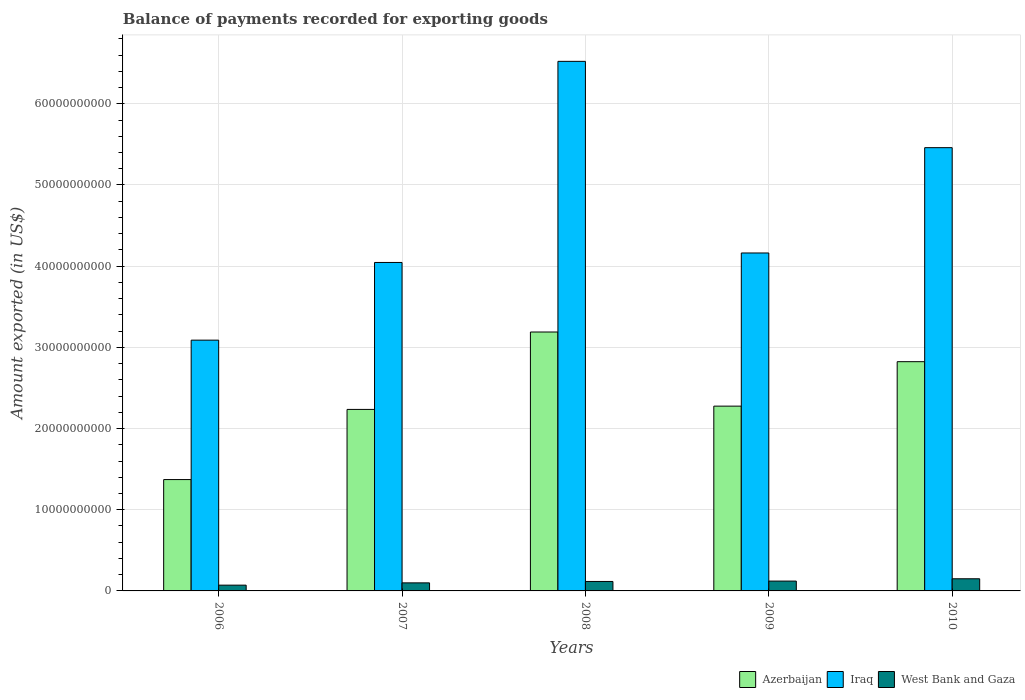Are the number of bars per tick equal to the number of legend labels?
Provide a succinct answer. Yes. Are the number of bars on each tick of the X-axis equal?
Make the answer very short. Yes. In how many cases, is the number of bars for a given year not equal to the number of legend labels?
Provide a succinct answer. 0. What is the amount exported in Iraq in 2009?
Give a very brief answer. 4.16e+1. Across all years, what is the maximum amount exported in Iraq?
Give a very brief answer. 6.52e+1. Across all years, what is the minimum amount exported in Azerbaijan?
Keep it short and to the point. 1.37e+1. In which year was the amount exported in West Bank and Gaza maximum?
Offer a terse response. 2010. In which year was the amount exported in West Bank and Gaza minimum?
Offer a terse response. 2006. What is the total amount exported in Iraq in the graph?
Your answer should be very brief. 2.33e+11. What is the difference between the amount exported in West Bank and Gaza in 2006 and that in 2009?
Provide a short and direct response. -5.00e+08. What is the difference between the amount exported in West Bank and Gaza in 2007 and the amount exported in Iraq in 2006?
Provide a short and direct response. -2.99e+1. What is the average amount exported in Iraq per year?
Give a very brief answer. 4.66e+1. In the year 2006, what is the difference between the amount exported in West Bank and Gaza and amount exported in Iraq?
Make the answer very short. -3.02e+1. What is the ratio of the amount exported in Iraq in 2006 to that in 2007?
Give a very brief answer. 0.76. Is the amount exported in Azerbaijan in 2006 less than that in 2009?
Make the answer very short. Yes. Is the difference between the amount exported in West Bank and Gaza in 2008 and 2009 greater than the difference between the amount exported in Iraq in 2008 and 2009?
Your answer should be compact. No. What is the difference between the highest and the second highest amount exported in Iraq?
Offer a terse response. 1.06e+1. What is the difference between the highest and the lowest amount exported in Iraq?
Provide a short and direct response. 3.43e+1. In how many years, is the amount exported in Azerbaijan greater than the average amount exported in Azerbaijan taken over all years?
Offer a very short reply. 2. What does the 3rd bar from the left in 2009 represents?
Provide a short and direct response. West Bank and Gaza. What does the 1st bar from the right in 2010 represents?
Your answer should be very brief. West Bank and Gaza. Is it the case that in every year, the sum of the amount exported in Azerbaijan and amount exported in Iraq is greater than the amount exported in West Bank and Gaza?
Make the answer very short. Yes. How many bars are there?
Ensure brevity in your answer.  15. What is the difference between two consecutive major ticks on the Y-axis?
Offer a terse response. 1.00e+1. Are the values on the major ticks of Y-axis written in scientific E-notation?
Your answer should be compact. No. Where does the legend appear in the graph?
Provide a succinct answer. Bottom right. How many legend labels are there?
Your answer should be compact. 3. What is the title of the graph?
Offer a very short reply. Balance of payments recorded for exporting goods. Does "Slovenia" appear as one of the legend labels in the graph?
Keep it short and to the point. No. What is the label or title of the Y-axis?
Your response must be concise. Amount exported (in US$). What is the Amount exported (in US$) of Azerbaijan in 2006?
Your answer should be very brief. 1.37e+1. What is the Amount exported (in US$) in Iraq in 2006?
Offer a very short reply. 3.09e+1. What is the Amount exported (in US$) of West Bank and Gaza in 2006?
Give a very brief answer. 7.10e+08. What is the Amount exported (in US$) of Azerbaijan in 2007?
Ensure brevity in your answer.  2.24e+1. What is the Amount exported (in US$) in Iraq in 2007?
Ensure brevity in your answer.  4.05e+1. What is the Amount exported (in US$) of West Bank and Gaza in 2007?
Ensure brevity in your answer.  9.93e+08. What is the Amount exported (in US$) in Azerbaijan in 2008?
Your response must be concise. 3.19e+1. What is the Amount exported (in US$) in Iraq in 2008?
Keep it short and to the point. 6.52e+1. What is the Amount exported (in US$) in West Bank and Gaza in 2008?
Offer a terse response. 1.16e+09. What is the Amount exported (in US$) in Azerbaijan in 2009?
Provide a succinct answer. 2.28e+1. What is the Amount exported (in US$) in Iraq in 2009?
Keep it short and to the point. 4.16e+1. What is the Amount exported (in US$) of West Bank and Gaza in 2009?
Offer a terse response. 1.21e+09. What is the Amount exported (in US$) of Azerbaijan in 2010?
Your response must be concise. 2.82e+1. What is the Amount exported (in US$) of Iraq in 2010?
Provide a short and direct response. 5.46e+1. What is the Amount exported (in US$) of West Bank and Gaza in 2010?
Offer a terse response. 1.50e+09. Across all years, what is the maximum Amount exported (in US$) of Azerbaijan?
Give a very brief answer. 3.19e+1. Across all years, what is the maximum Amount exported (in US$) in Iraq?
Provide a short and direct response. 6.52e+1. Across all years, what is the maximum Amount exported (in US$) in West Bank and Gaza?
Give a very brief answer. 1.50e+09. Across all years, what is the minimum Amount exported (in US$) of Azerbaijan?
Provide a short and direct response. 1.37e+1. Across all years, what is the minimum Amount exported (in US$) of Iraq?
Your response must be concise. 3.09e+1. Across all years, what is the minimum Amount exported (in US$) in West Bank and Gaza?
Offer a very short reply. 7.10e+08. What is the total Amount exported (in US$) of Azerbaijan in the graph?
Your answer should be compact. 1.19e+11. What is the total Amount exported (in US$) in Iraq in the graph?
Your response must be concise. 2.33e+11. What is the total Amount exported (in US$) in West Bank and Gaza in the graph?
Give a very brief answer. 5.57e+09. What is the difference between the Amount exported (in US$) of Azerbaijan in 2006 and that in 2007?
Your answer should be compact. -8.64e+09. What is the difference between the Amount exported (in US$) in Iraq in 2006 and that in 2007?
Keep it short and to the point. -9.57e+09. What is the difference between the Amount exported (in US$) in West Bank and Gaza in 2006 and that in 2007?
Provide a succinct answer. -2.82e+08. What is the difference between the Amount exported (in US$) in Azerbaijan in 2006 and that in 2008?
Offer a very short reply. -1.82e+1. What is the difference between the Amount exported (in US$) of Iraq in 2006 and that in 2008?
Give a very brief answer. -3.43e+1. What is the difference between the Amount exported (in US$) of West Bank and Gaza in 2006 and that in 2008?
Provide a short and direct response. -4.54e+08. What is the difference between the Amount exported (in US$) of Azerbaijan in 2006 and that in 2009?
Your answer should be very brief. -9.04e+09. What is the difference between the Amount exported (in US$) in Iraq in 2006 and that in 2009?
Your response must be concise. -1.07e+1. What is the difference between the Amount exported (in US$) in West Bank and Gaza in 2006 and that in 2009?
Make the answer very short. -5.00e+08. What is the difference between the Amount exported (in US$) in Azerbaijan in 2006 and that in 2010?
Provide a succinct answer. -1.45e+1. What is the difference between the Amount exported (in US$) in Iraq in 2006 and that in 2010?
Make the answer very short. -2.37e+1. What is the difference between the Amount exported (in US$) of West Bank and Gaza in 2006 and that in 2010?
Your response must be concise. -7.87e+08. What is the difference between the Amount exported (in US$) in Azerbaijan in 2007 and that in 2008?
Offer a terse response. -9.53e+09. What is the difference between the Amount exported (in US$) in Iraq in 2007 and that in 2008?
Offer a terse response. -2.48e+1. What is the difference between the Amount exported (in US$) in West Bank and Gaza in 2007 and that in 2008?
Offer a very short reply. -1.72e+08. What is the difference between the Amount exported (in US$) of Azerbaijan in 2007 and that in 2009?
Your answer should be very brief. -4.04e+08. What is the difference between the Amount exported (in US$) of Iraq in 2007 and that in 2009?
Your answer should be very brief. -1.17e+09. What is the difference between the Amount exported (in US$) in West Bank and Gaza in 2007 and that in 2009?
Offer a very short reply. -2.18e+08. What is the difference between the Amount exported (in US$) of Azerbaijan in 2007 and that in 2010?
Offer a terse response. -5.88e+09. What is the difference between the Amount exported (in US$) in Iraq in 2007 and that in 2010?
Your answer should be compact. -1.41e+1. What is the difference between the Amount exported (in US$) in West Bank and Gaza in 2007 and that in 2010?
Give a very brief answer. -5.04e+08. What is the difference between the Amount exported (in US$) of Azerbaijan in 2008 and that in 2009?
Provide a succinct answer. 9.13e+09. What is the difference between the Amount exported (in US$) of Iraq in 2008 and that in 2009?
Keep it short and to the point. 2.36e+1. What is the difference between the Amount exported (in US$) of West Bank and Gaza in 2008 and that in 2009?
Your answer should be compact. -4.61e+07. What is the difference between the Amount exported (in US$) of Azerbaijan in 2008 and that in 2010?
Provide a succinct answer. 3.65e+09. What is the difference between the Amount exported (in US$) of Iraq in 2008 and that in 2010?
Make the answer very short. 1.06e+1. What is the difference between the Amount exported (in US$) in West Bank and Gaza in 2008 and that in 2010?
Keep it short and to the point. -3.32e+08. What is the difference between the Amount exported (in US$) in Azerbaijan in 2009 and that in 2010?
Your answer should be very brief. -5.48e+09. What is the difference between the Amount exported (in US$) of Iraq in 2009 and that in 2010?
Your response must be concise. -1.30e+1. What is the difference between the Amount exported (in US$) of West Bank and Gaza in 2009 and that in 2010?
Make the answer very short. -2.86e+08. What is the difference between the Amount exported (in US$) of Azerbaijan in 2006 and the Amount exported (in US$) of Iraq in 2007?
Your answer should be compact. -2.67e+1. What is the difference between the Amount exported (in US$) in Azerbaijan in 2006 and the Amount exported (in US$) in West Bank and Gaza in 2007?
Ensure brevity in your answer.  1.27e+1. What is the difference between the Amount exported (in US$) of Iraq in 2006 and the Amount exported (in US$) of West Bank and Gaza in 2007?
Give a very brief answer. 2.99e+1. What is the difference between the Amount exported (in US$) in Azerbaijan in 2006 and the Amount exported (in US$) in Iraq in 2008?
Offer a very short reply. -5.15e+1. What is the difference between the Amount exported (in US$) of Azerbaijan in 2006 and the Amount exported (in US$) of West Bank and Gaza in 2008?
Your response must be concise. 1.25e+1. What is the difference between the Amount exported (in US$) of Iraq in 2006 and the Amount exported (in US$) of West Bank and Gaza in 2008?
Provide a short and direct response. 2.97e+1. What is the difference between the Amount exported (in US$) of Azerbaijan in 2006 and the Amount exported (in US$) of Iraq in 2009?
Offer a very short reply. -2.79e+1. What is the difference between the Amount exported (in US$) in Azerbaijan in 2006 and the Amount exported (in US$) in West Bank and Gaza in 2009?
Make the answer very short. 1.25e+1. What is the difference between the Amount exported (in US$) in Iraq in 2006 and the Amount exported (in US$) in West Bank and Gaza in 2009?
Provide a short and direct response. 2.97e+1. What is the difference between the Amount exported (in US$) of Azerbaijan in 2006 and the Amount exported (in US$) of Iraq in 2010?
Give a very brief answer. -4.09e+1. What is the difference between the Amount exported (in US$) of Azerbaijan in 2006 and the Amount exported (in US$) of West Bank and Gaza in 2010?
Provide a succinct answer. 1.22e+1. What is the difference between the Amount exported (in US$) of Iraq in 2006 and the Amount exported (in US$) of West Bank and Gaza in 2010?
Your answer should be very brief. 2.94e+1. What is the difference between the Amount exported (in US$) of Azerbaijan in 2007 and the Amount exported (in US$) of Iraq in 2008?
Offer a very short reply. -4.29e+1. What is the difference between the Amount exported (in US$) of Azerbaijan in 2007 and the Amount exported (in US$) of West Bank and Gaza in 2008?
Provide a short and direct response. 2.12e+1. What is the difference between the Amount exported (in US$) of Iraq in 2007 and the Amount exported (in US$) of West Bank and Gaza in 2008?
Your answer should be very brief. 3.93e+1. What is the difference between the Amount exported (in US$) in Azerbaijan in 2007 and the Amount exported (in US$) in Iraq in 2009?
Your answer should be compact. -1.93e+1. What is the difference between the Amount exported (in US$) of Azerbaijan in 2007 and the Amount exported (in US$) of West Bank and Gaza in 2009?
Your answer should be compact. 2.11e+1. What is the difference between the Amount exported (in US$) in Iraq in 2007 and the Amount exported (in US$) in West Bank and Gaza in 2009?
Your response must be concise. 3.92e+1. What is the difference between the Amount exported (in US$) in Azerbaijan in 2007 and the Amount exported (in US$) in Iraq in 2010?
Offer a very short reply. -3.22e+1. What is the difference between the Amount exported (in US$) of Azerbaijan in 2007 and the Amount exported (in US$) of West Bank and Gaza in 2010?
Offer a very short reply. 2.09e+1. What is the difference between the Amount exported (in US$) of Iraq in 2007 and the Amount exported (in US$) of West Bank and Gaza in 2010?
Ensure brevity in your answer.  3.90e+1. What is the difference between the Amount exported (in US$) in Azerbaijan in 2008 and the Amount exported (in US$) in Iraq in 2009?
Provide a succinct answer. -9.73e+09. What is the difference between the Amount exported (in US$) in Azerbaijan in 2008 and the Amount exported (in US$) in West Bank and Gaza in 2009?
Your response must be concise. 3.07e+1. What is the difference between the Amount exported (in US$) of Iraq in 2008 and the Amount exported (in US$) of West Bank and Gaza in 2009?
Keep it short and to the point. 6.40e+1. What is the difference between the Amount exported (in US$) in Azerbaijan in 2008 and the Amount exported (in US$) in Iraq in 2010?
Offer a very short reply. -2.27e+1. What is the difference between the Amount exported (in US$) of Azerbaijan in 2008 and the Amount exported (in US$) of West Bank and Gaza in 2010?
Your answer should be compact. 3.04e+1. What is the difference between the Amount exported (in US$) in Iraq in 2008 and the Amount exported (in US$) in West Bank and Gaza in 2010?
Your response must be concise. 6.37e+1. What is the difference between the Amount exported (in US$) of Azerbaijan in 2009 and the Amount exported (in US$) of Iraq in 2010?
Your answer should be very brief. -3.18e+1. What is the difference between the Amount exported (in US$) of Azerbaijan in 2009 and the Amount exported (in US$) of West Bank and Gaza in 2010?
Offer a very short reply. 2.13e+1. What is the difference between the Amount exported (in US$) of Iraq in 2009 and the Amount exported (in US$) of West Bank and Gaza in 2010?
Keep it short and to the point. 4.01e+1. What is the average Amount exported (in US$) in Azerbaijan per year?
Ensure brevity in your answer.  2.38e+1. What is the average Amount exported (in US$) of Iraq per year?
Offer a terse response. 4.66e+1. What is the average Amount exported (in US$) of West Bank and Gaza per year?
Your response must be concise. 1.11e+09. In the year 2006, what is the difference between the Amount exported (in US$) in Azerbaijan and Amount exported (in US$) in Iraq?
Ensure brevity in your answer.  -1.72e+1. In the year 2006, what is the difference between the Amount exported (in US$) of Azerbaijan and Amount exported (in US$) of West Bank and Gaza?
Provide a short and direct response. 1.30e+1. In the year 2006, what is the difference between the Amount exported (in US$) in Iraq and Amount exported (in US$) in West Bank and Gaza?
Your answer should be compact. 3.02e+1. In the year 2007, what is the difference between the Amount exported (in US$) of Azerbaijan and Amount exported (in US$) of Iraq?
Give a very brief answer. -1.81e+1. In the year 2007, what is the difference between the Amount exported (in US$) in Azerbaijan and Amount exported (in US$) in West Bank and Gaza?
Give a very brief answer. 2.14e+1. In the year 2007, what is the difference between the Amount exported (in US$) in Iraq and Amount exported (in US$) in West Bank and Gaza?
Ensure brevity in your answer.  3.95e+1. In the year 2008, what is the difference between the Amount exported (in US$) of Azerbaijan and Amount exported (in US$) of Iraq?
Your answer should be very brief. -3.33e+1. In the year 2008, what is the difference between the Amount exported (in US$) of Azerbaijan and Amount exported (in US$) of West Bank and Gaza?
Give a very brief answer. 3.07e+1. In the year 2008, what is the difference between the Amount exported (in US$) in Iraq and Amount exported (in US$) in West Bank and Gaza?
Provide a short and direct response. 6.41e+1. In the year 2009, what is the difference between the Amount exported (in US$) of Azerbaijan and Amount exported (in US$) of Iraq?
Keep it short and to the point. -1.89e+1. In the year 2009, what is the difference between the Amount exported (in US$) of Azerbaijan and Amount exported (in US$) of West Bank and Gaza?
Keep it short and to the point. 2.15e+1. In the year 2009, what is the difference between the Amount exported (in US$) of Iraq and Amount exported (in US$) of West Bank and Gaza?
Provide a succinct answer. 4.04e+1. In the year 2010, what is the difference between the Amount exported (in US$) in Azerbaijan and Amount exported (in US$) in Iraq?
Provide a succinct answer. -2.64e+1. In the year 2010, what is the difference between the Amount exported (in US$) in Azerbaijan and Amount exported (in US$) in West Bank and Gaza?
Ensure brevity in your answer.  2.67e+1. In the year 2010, what is the difference between the Amount exported (in US$) of Iraq and Amount exported (in US$) of West Bank and Gaza?
Keep it short and to the point. 5.31e+1. What is the ratio of the Amount exported (in US$) in Azerbaijan in 2006 to that in 2007?
Make the answer very short. 0.61. What is the ratio of the Amount exported (in US$) in Iraq in 2006 to that in 2007?
Ensure brevity in your answer.  0.76. What is the ratio of the Amount exported (in US$) in West Bank and Gaza in 2006 to that in 2007?
Your answer should be very brief. 0.72. What is the ratio of the Amount exported (in US$) in Azerbaijan in 2006 to that in 2008?
Give a very brief answer. 0.43. What is the ratio of the Amount exported (in US$) of Iraq in 2006 to that in 2008?
Ensure brevity in your answer.  0.47. What is the ratio of the Amount exported (in US$) of West Bank and Gaza in 2006 to that in 2008?
Give a very brief answer. 0.61. What is the ratio of the Amount exported (in US$) in Azerbaijan in 2006 to that in 2009?
Offer a terse response. 0.6. What is the ratio of the Amount exported (in US$) of Iraq in 2006 to that in 2009?
Make the answer very short. 0.74. What is the ratio of the Amount exported (in US$) of West Bank and Gaza in 2006 to that in 2009?
Your response must be concise. 0.59. What is the ratio of the Amount exported (in US$) of Azerbaijan in 2006 to that in 2010?
Your answer should be very brief. 0.49. What is the ratio of the Amount exported (in US$) in Iraq in 2006 to that in 2010?
Give a very brief answer. 0.57. What is the ratio of the Amount exported (in US$) in West Bank and Gaza in 2006 to that in 2010?
Offer a terse response. 0.47. What is the ratio of the Amount exported (in US$) in Azerbaijan in 2007 to that in 2008?
Your answer should be very brief. 0.7. What is the ratio of the Amount exported (in US$) of Iraq in 2007 to that in 2008?
Your response must be concise. 0.62. What is the ratio of the Amount exported (in US$) of West Bank and Gaza in 2007 to that in 2008?
Provide a succinct answer. 0.85. What is the ratio of the Amount exported (in US$) in Azerbaijan in 2007 to that in 2009?
Your response must be concise. 0.98. What is the ratio of the Amount exported (in US$) in Iraq in 2007 to that in 2009?
Make the answer very short. 0.97. What is the ratio of the Amount exported (in US$) of West Bank and Gaza in 2007 to that in 2009?
Make the answer very short. 0.82. What is the ratio of the Amount exported (in US$) of Azerbaijan in 2007 to that in 2010?
Offer a very short reply. 0.79. What is the ratio of the Amount exported (in US$) in Iraq in 2007 to that in 2010?
Provide a short and direct response. 0.74. What is the ratio of the Amount exported (in US$) in West Bank and Gaza in 2007 to that in 2010?
Give a very brief answer. 0.66. What is the ratio of the Amount exported (in US$) of Azerbaijan in 2008 to that in 2009?
Offer a terse response. 1.4. What is the ratio of the Amount exported (in US$) in Iraq in 2008 to that in 2009?
Offer a very short reply. 1.57. What is the ratio of the Amount exported (in US$) of West Bank and Gaza in 2008 to that in 2009?
Provide a short and direct response. 0.96. What is the ratio of the Amount exported (in US$) in Azerbaijan in 2008 to that in 2010?
Your answer should be compact. 1.13. What is the ratio of the Amount exported (in US$) in Iraq in 2008 to that in 2010?
Your response must be concise. 1.19. What is the ratio of the Amount exported (in US$) of West Bank and Gaza in 2008 to that in 2010?
Give a very brief answer. 0.78. What is the ratio of the Amount exported (in US$) in Azerbaijan in 2009 to that in 2010?
Keep it short and to the point. 0.81. What is the ratio of the Amount exported (in US$) of Iraq in 2009 to that in 2010?
Your answer should be compact. 0.76. What is the ratio of the Amount exported (in US$) of West Bank and Gaza in 2009 to that in 2010?
Provide a short and direct response. 0.81. What is the difference between the highest and the second highest Amount exported (in US$) in Azerbaijan?
Offer a terse response. 3.65e+09. What is the difference between the highest and the second highest Amount exported (in US$) in Iraq?
Make the answer very short. 1.06e+1. What is the difference between the highest and the second highest Amount exported (in US$) of West Bank and Gaza?
Give a very brief answer. 2.86e+08. What is the difference between the highest and the lowest Amount exported (in US$) in Azerbaijan?
Ensure brevity in your answer.  1.82e+1. What is the difference between the highest and the lowest Amount exported (in US$) of Iraq?
Your answer should be compact. 3.43e+1. What is the difference between the highest and the lowest Amount exported (in US$) in West Bank and Gaza?
Your answer should be very brief. 7.87e+08. 